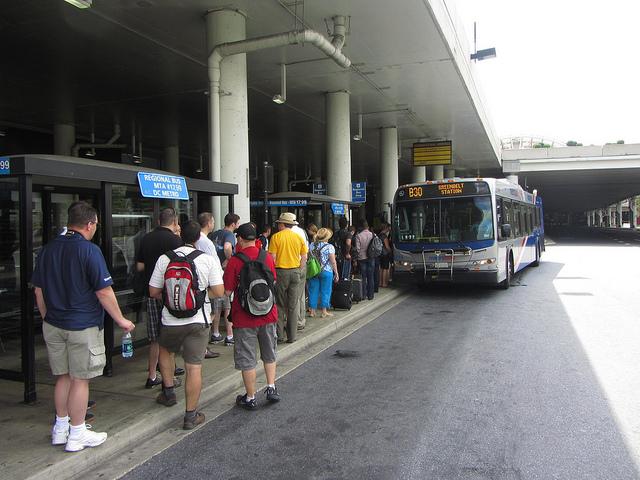Are many people waiting?
Be succinct. Yes. Where is this taken place?
Short answer required. Bus station. What kind of transportation is this?
Quick response, please. Bus. 